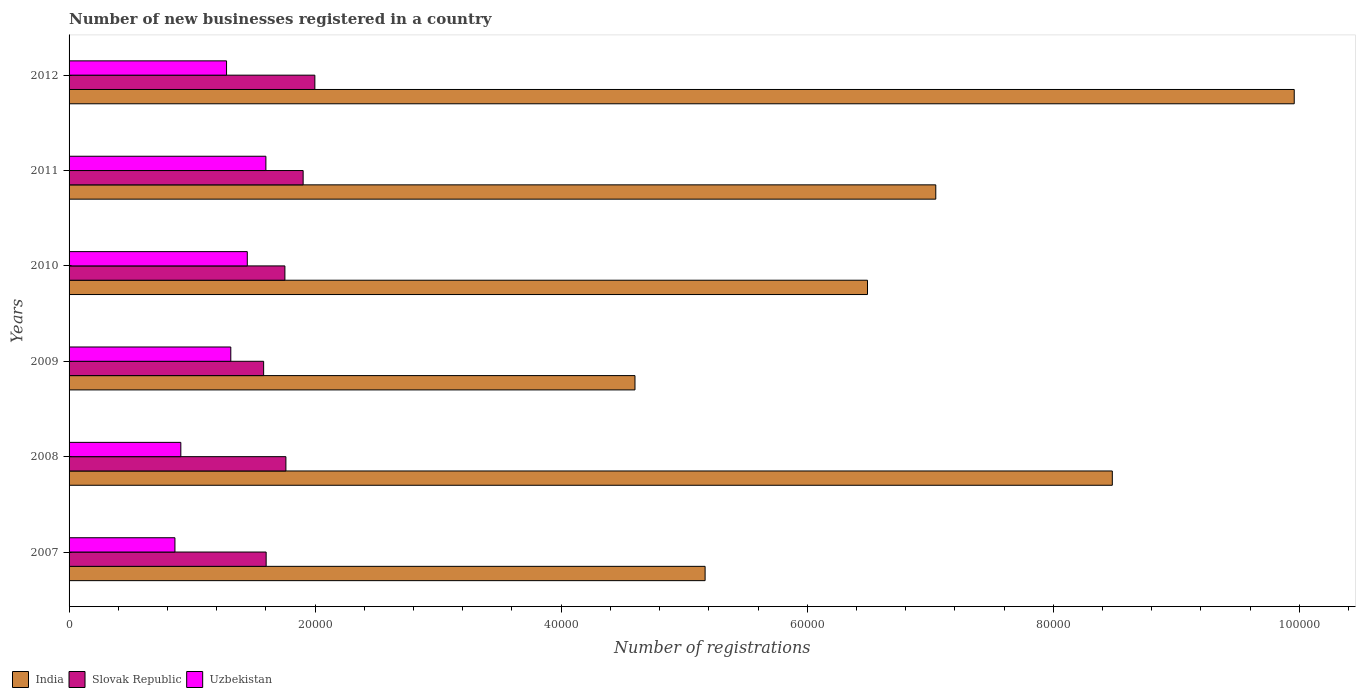How many different coloured bars are there?
Ensure brevity in your answer.  3. How many groups of bars are there?
Keep it short and to the point. 6. Are the number of bars per tick equal to the number of legend labels?
Give a very brief answer. Yes. What is the label of the 5th group of bars from the top?
Offer a terse response. 2008. In how many cases, is the number of bars for a given year not equal to the number of legend labels?
Make the answer very short. 0. What is the number of new businesses registered in Slovak Republic in 2007?
Make the answer very short. 1.60e+04. Across all years, what is the maximum number of new businesses registered in India?
Give a very brief answer. 9.96e+04. Across all years, what is the minimum number of new businesses registered in Slovak Republic?
Your answer should be very brief. 1.58e+04. In which year was the number of new businesses registered in Slovak Republic minimum?
Ensure brevity in your answer.  2009. What is the total number of new businesses registered in Uzbekistan in the graph?
Provide a short and direct response. 7.41e+04. What is the difference between the number of new businesses registered in India in 2010 and that in 2011?
Ensure brevity in your answer.  -5550. What is the difference between the number of new businesses registered in Uzbekistan in 2011 and the number of new businesses registered in Slovak Republic in 2008?
Offer a terse response. -1626. What is the average number of new businesses registered in Slovak Republic per year?
Your answer should be compact. 1.77e+04. In the year 2012, what is the difference between the number of new businesses registered in Slovak Republic and number of new businesses registered in Uzbekistan?
Provide a short and direct response. 7178. What is the ratio of the number of new businesses registered in Uzbekistan in 2007 to that in 2011?
Offer a terse response. 0.54. Is the difference between the number of new businesses registered in Slovak Republic in 2007 and 2010 greater than the difference between the number of new businesses registered in Uzbekistan in 2007 and 2010?
Offer a very short reply. Yes. What is the difference between the highest and the second highest number of new businesses registered in India?
Your answer should be compact. 1.48e+04. What is the difference between the highest and the lowest number of new businesses registered in Slovak Republic?
Provide a succinct answer. 4164. What does the 3rd bar from the top in 2011 represents?
Offer a very short reply. India. What does the 3rd bar from the bottom in 2011 represents?
Provide a short and direct response. Uzbekistan. Is it the case that in every year, the sum of the number of new businesses registered in Slovak Republic and number of new businesses registered in India is greater than the number of new businesses registered in Uzbekistan?
Offer a very short reply. Yes. How many years are there in the graph?
Your answer should be compact. 6. Does the graph contain any zero values?
Your response must be concise. No. How are the legend labels stacked?
Offer a very short reply. Horizontal. What is the title of the graph?
Keep it short and to the point. Number of new businesses registered in a country. Does "United Kingdom" appear as one of the legend labels in the graph?
Keep it short and to the point. No. What is the label or title of the X-axis?
Make the answer very short. Number of registrations. What is the label or title of the Y-axis?
Give a very brief answer. Years. What is the Number of registrations of India in 2007?
Keep it short and to the point. 5.17e+04. What is the Number of registrations in Slovak Republic in 2007?
Offer a terse response. 1.60e+04. What is the Number of registrations of Uzbekistan in 2007?
Give a very brief answer. 8605. What is the Number of registrations in India in 2008?
Provide a short and direct response. 8.48e+04. What is the Number of registrations of Slovak Republic in 2008?
Make the answer very short. 1.76e+04. What is the Number of registrations of Uzbekistan in 2008?
Ensure brevity in your answer.  9084. What is the Number of registrations of India in 2009?
Provide a succinct answer. 4.60e+04. What is the Number of registrations of Slovak Republic in 2009?
Keep it short and to the point. 1.58e+04. What is the Number of registrations in Uzbekistan in 2009?
Make the answer very short. 1.31e+04. What is the Number of registrations of India in 2010?
Offer a very short reply. 6.49e+04. What is the Number of registrations in Slovak Republic in 2010?
Ensure brevity in your answer.  1.75e+04. What is the Number of registrations in Uzbekistan in 2010?
Provide a succinct answer. 1.45e+04. What is the Number of registrations of India in 2011?
Provide a short and direct response. 7.04e+04. What is the Number of registrations in Slovak Republic in 2011?
Offer a terse response. 1.90e+04. What is the Number of registrations in Uzbekistan in 2011?
Provide a short and direct response. 1.60e+04. What is the Number of registrations of India in 2012?
Your response must be concise. 9.96e+04. What is the Number of registrations of Slovak Republic in 2012?
Keep it short and to the point. 2.00e+04. What is the Number of registrations of Uzbekistan in 2012?
Keep it short and to the point. 1.28e+04. Across all years, what is the maximum Number of registrations in India?
Offer a terse response. 9.96e+04. Across all years, what is the maximum Number of registrations in Slovak Republic?
Make the answer very short. 2.00e+04. Across all years, what is the maximum Number of registrations in Uzbekistan?
Keep it short and to the point. 1.60e+04. Across all years, what is the minimum Number of registrations of India?
Ensure brevity in your answer.  4.60e+04. Across all years, what is the minimum Number of registrations in Slovak Republic?
Keep it short and to the point. 1.58e+04. Across all years, what is the minimum Number of registrations of Uzbekistan?
Make the answer very short. 8605. What is the total Number of registrations of India in the graph?
Provide a succinct answer. 4.17e+05. What is the total Number of registrations of Slovak Republic in the graph?
Give a very brief answer. 1.06e+05. What is the total Number of registrations of Uzbekistan in the graph?
Your response must be concise. 7.41e+04. What is the difference between the Number of registrations in India in 2007 and that in 2008?
Ensure brevity in your answer.  -3.31e+04. What is the difference between the Number of registrations in Slovak Republic in 2007 and that in 2008?
Make the answer very short. -1605. What is the difference between the Number of registrations in Uzbekistan in 2007 and that in 2008?
Your answer should be very brief. -479. What is the difference between the Number of registrations in India in 2007 and that in 2009?
Provide a succinct answer. 5700. What is the difference between the Number of registrations in Slovak Republic in 2007 and that in 2009?
Offer a terse response. 205. What is the difference between the Number of registrations in Uzbekistan in 2007 and that in 2009?
Your response must be concise. -4541. What is the difference between the Number of registrations of India in 2007 and that in 2010?
Provide a short and direct response. -1.32e+04. What is the difference between the Number of registrations in Slovak Republic in 2007 and that in 2010?
Keep it short and to the point. -1524. What is the difference between the Number of registrations in Uzbekistan in 2007 and that in 2010?
Give a very brief answer. -5882. What is the difference between the Number of registrations of India in 2007 and that in 2011?
Your response must be concise. -1.88e+04. What is the difference between the Number of registrations in Slovak Republic in 2007 and that in 2011?
Keep it short and to the point. -3006. What is the difference between the Number of registrations in Uzbekistan in 2007 and that in 2011?
Offer a very short reply. -7394. What is the difference between the Number of registrations in India in 2007 and that in 2012?
Provide a succinct answer. -4.79e+04. What is the difference between the Number of registrations of Slovak Republic in 2007 and that in 2012?
Your answer should be very brief. -3959. What is the difference between the Number of registrations of Uzbekistan in 2007 and that in 2012?
Your answer should be very brief. -4196. What is the difference between the Number of registrations of India in 2008 and that in 2009?
Ensure brevity in your answer.  3.88e+04. What is the difference between the Number of registrations of Slovak Republic in 2008 and that in 2009?
Ensure brevity in your answer.  1810. What is the difference between the Number of registrations in Uzbekistan in 2008 and that in 2009?
Your answer should be very brief. -4062. What is the difference between the Number of registrations of India in 2008 and that in 2010?
Offer a very short reply. 1.99e+04. What is the difference between the Number of registrations in Slovak Republic in 2008 and that in 2010?
Offer a terse response. 81. What is the difference between the Number of registrations of Uzbekistan in 2008 and that in 2010?
Provide a short and direct response. -5403. What is the difference between the Number of registrations of India in 2008 and that in 2011?
Your answer should be compact. 1.44e+04. What is the difference between the Number of registrations of Slovak Republic in 2008 and that in 2011?
Give a very brief answer. -1401. What is the difference between the Number of registrations in Uzbekistan in 2008 and that in 2011?
Your answer should be very brief. -6915. What is the difference between the Number of registrations in India in 2008 and that in 2012?
Give a very brief answer. -1.48e+04. What is the difference between the Number of registrations of Slovak Republic in 2008 and that in 2012?
Ensure brevity in your answer.  -2354. What is the difference between the Number of registrations of Uzbekistan in 2008 and that in 2012?
Keep it short and to the point. -3717. What is the difference between the Number of registrations in India in 2009 and that in 2010?
Your response must be concise. -1.89e+04. What is the difference between the Number of registrations in Slovak Republic in 2009 and that in 2010?
Your answer should be compact. -1729. What is the difference between the Number of registrations in Uzbekistan in 2009 and that in 2010?
Provide a short and direct response. -1341. What is the difference between the Number of registrations of India in 2009 and that in 2011?
Your answer should be very brief. -2.44e+04. What is the difference between the Number of registrations in Slovak Republic in 2009 and that in 2011?
Offer a very short reply. -3211. What is the difference between the Number of registrations in Uzbekistan in 2009 and that in 2011?
Give a very brief answer. -2853. What is the difference between the Number of registrations in India in 2009 and that in 2012?
Offer a very short reply. -5.36e+04. What is the difference between the Number of registrations of Slovak Republic in 2009 and that in 2012?
Ensure brevity in your answer.  -4164. What is the difference between the Number of registrations in Uzbekistan in 2009 and that in 2012?
Keep it short and to the point. 345. What is the difference between the Number of registrations of India in 2010 and that in 2011?
Your answer should be very brief. -5550. What is the difference between the Number of registrations of Slovak Republic in 2010 and that in 2011?
Your answer should be very brief. -1482. What is the difference between the Number of registrations of Uzbekistan in 2010 and that in 2011?
Give a very brief answer. -1512. What is the difference between the Number of registrations in India in 2010 and that in 2012?
Your answer should be compact. -3.47e+04. What is the difference between the Number of registrations of Slovak Republic in 2010 and that in 2012?
Offer a very short reply. -2435. What is the difference between the Number of registrations of Uzbekistan in 2010 and that in 2012?
Your response must be concise. 1686. What is the difference between the Number of registrations in India in 2011 and that in 2012?
Your response must be concise. -2.91e+04. What is the difference between the Number of registrations of Slovak Republic in 2011 and that in 2012?
Make the answer very short. -953. What is the difference between the Number of registrations in Uzbekistan in 2011 and that in 2012?
Offer a very short reply. 3198. What is the difference between the Number of registrations in India in 2007 and the Number of registrations in Slovak Republic in 2008?
Offer a very short reply. 3.41e+04. What is the difference between the Number of registrations in India in 2007 and the Number of registrations in Uzbekistan in 2008?
Your answer should be compact. 4.26e+04. What is the difference between the Number of registrations of Slovak Republic in 2007 and the Number of registrations of Uzbekistan in 2008?
Your response must be concise. 6936. What is the difference between the Number of registrations in India in 2007 and the Number of registrations in Slovak Republic in 2009?
Your response must be concise. 3.59e+04. What is the difference between the Number of registrations of India in 2007 and the Number of registrations of Uzbekistan in 2009?
Keep it short and to the point. 3.86e+04. What is the difference between the Number of registrations of Slovak Republic in 2007 and the Number of registrations of Uzbekistan in 2009?
Ensure brevity in your answer.  2874. What is the difference between the Number of registrations of India in 2007 and the Number of registrations of Slovak Republic in 2010?
Make the answer very short. 3.42e+04. What is the difference between the Number of registrations of India in 2007 and the Number of registrations of Uzbekistan in 2010?
Provide a short and direct response. 3.72e+04. What is the difference between the Number of registrations of Slovak Republic in 2007 and the Number of registrations of Uzbekistan in 2010?
Your answer should be very brief. 1533. What is the difference between the Number of registrations in India in 2007 and the Number of registrations in Slovak Republic in 2011?
Offer a very short reply. 3.27e+04. What is the difference between the Number of registrations of India in 2007 and the Number of registrations of Uzbekistan in 2011?
Your response must be concise. 3.57e+04. What is the difference between the Number of registrations in Slovak Republic in 2007 and the Number of registrations in Uzbekistan in 2011?
Give a very brief answer. 21. What is the difference between the Number of registrations of India in 2007 and the Number of registrations of Slovak Republic in 2012?
Ensure brevity in your answer.  3.17e+04. What is the difference between the Number of registrations of India in 2007 and the Number of registrations of Uzbekistan in 2012?
Make the answer very short. 3.89e+04. What is the difference between the Number of registrations of Slovak Republic in 2007 and the Number of registrations of Uzbekistan in 2012?
Provide a short and direct response. 3219. What is the difference between the Number of registrations in India in 2008 and the Number of registrations in Slovak Republic in 2009?
Provide a short and direct response. 6.90e+04. What is the difference between the Number of registrations in India in 2008 and the Number of registrations in Uzbekistan in 2009?
Provide a succinct answer. 7.17e+04. What is the difference between the Number of registrations of Slovak Republic in 2008 and the Number of registrations of Uzbekistan in 2009?
Your answer should be compact. 4479. What is the difference between the Number of registrations of India in 2008 and the Number of registrations of Slovak Republic in 2010?
Your response must be concise. 6.73e+04. What is the difference between the Number of registrations in India in 2008 and the Number of registrations in Uzbekistan in 2010?
Your answer should be very brief. 7.03e+04. What is the difference between the Number of registrations of Slovak Republic in 2008 and the Number of registrations of Uzbekistan in 2010?
Offer a terse response. 3138. What is the difference between the Number of registrations of India in 2008 and the Number of registrations of Slovak Republic in 2011?
Your answer should be compact. 6.58e+04. What is the difference between the Number of registrations in India in 2008 and the Number of registrations in Uzbekistan in 2011?
Offer a terse response. 6.88e+04. What is the difference between the Number of registrations of Slovak Republic in 2008 and the Number of registrations of Uzbekistan in 2011?
Provide a short and direct response. 1626. What is the difference between the Number of registrations in India in 2008 and the Number of registrations in Slovak Republic in 2012?
Provide a short and direct response. 6.48e+04. What is the difference between the Number of registrations in India in 2008 and the Number of registrations in Uzbekistan in 2012?
Your answer should be very brief. 7.20e+04. What is the difference between the Number of registrations in Slovak Republic in 2008 and the Number of registrations in Uzbekistan in 2012?
Make the answer very short. 4824. What is the difference between the Number of registrations of India in 2009 and the Number of registrations of Slovak Republic in 2010?
Your answer should be very brief. 2.85e+04. What is the difference between the Number of registrations in India in 2009 and the Number of registrations in Uzbekistan in 2010?
Your answer should be compact. 3.15e+04. What is the difference between the Number of registrations of Slovak Republic in 2009 and the Number of registrations of Uzbekistan in 2010?
Your response must be concise. 1328. What is the difference between the Number of registrations of India in 2009 and the Number of registrations of Slovak Republic in 2011?
Offer a terse response. 2.70e+04. What is the difference between the Number of registrations of India in 2009 and the Number of registrations of Uzbekistan in 2011?
Provide a short and direct response. 3.00e+04. What is the difference between the Number of registrations of Slovak Republic in 2009 and the Number of registrations of Uzbekistan in 2011?
Your answer should be very brief. -184. What is the difference between the Number of registrations in India in 2009 and the Number of registrations in Slovak Republic in 2012?
Give a very brief answer. 2.60e+04. What is the difference between the Number of registrations in India in 2009 and the Number of registrations in Uzbekistan in 2012?
Keep it short and to the point. 3.32e+04. What is the difference between the Number of registrations in Slovak Republic in 2009 and the Number of registrations in Uzbekistan in 2012?
Provide a succinct answer. 3014. What is the difference between the Number of registrations of India in 2010 and the Number of registrations of Slovak Republic in 2011?
Offer a very short reply. 4.59e+04. What is the difference between the Number of registrations in India in 2010 and the Number of registrations in Uzbekistan in 2011?
Provide a short and direct response. 4.89e+04. What is the difference between the Number of registrations in Slovak Republic in 2010 and the Number of registrations in Uzbekistan in 2011?
Give a very brief answer. 1545. What is the difference between the Number of registrations of India in 2010 and the Number of registrations of Slovak Republic in 2012?
Your answer should be very brief. 4.49e+04. What is the difference between the Number of registrations of India in 2010 and the Number of registrations of Uzbekistan in 2012?
Ensure brevity in your answer.  5.21e+04. What is the difference between the Number of registrations in Slovak Republic in 2010 and the Number of registrations in Uzbekistan in 2012?
Offer a very short reply. 4743. What is the difference between the Number of registrations in India in 2011 and the Number of registrations in Slovak Republic in 2012?
Your answer should be very brief. 5.05e+04. What is the difference between the Number of registrations in India in 2011 and the Number of registrations in Uzbekistan in 2012?
Your answer should be very brief. 5.76e+04. What is the difference between the Number of registrations in Slovak Republic in 2011 and the Number of registrations in Uzbekistan in 2012?
Provide a succinct answer. 6225. What is the average Number of registrations of India per year?
Keep it short and to the point. 6.96e+04. What is the average Number of registrations in Slovak Republic per year?
Make the answer very short. 1.77e+04. What is the average Number of registrations in Uzbekistan per year?
Your answer should be very brief. 1.24e+04. In the year 2007, what is the difference between the Number of registrations in India and Number of registrations in Slovak Republic?
Make the answer very short. 3.57e+04. In the year 2007, what is the difference between the Number of registrations of India and Number of registrations of Uzbekistan?
Provide a succinct answer. 4.31e+04. In the year 2007, what is the difference between the Number of registrations in Slovak Republic and Number of registrations in Uzbekistan?
Your answer should be very brief. 7415. In the year 2008, what is the difference between the Number of registrations in India and Number of registrations in Slovak Republic?
Your answer should be very brief. 6.72e+04. In the year 2008, what is the difference between the Number of registrations in India and Number of registrations in Uzbekistan?
Keep it short and to the point. 7.57e+04. In the year 2008, what is the difference between the Number of registrations in Slovak Republic and Number of registrations in Uzbekistan?
Your response must be concise. 8541. In the year 2009, what is the difference between the Number of registrations of India and Number of registrations of Slovak Republic?
Your answer should be very brief. 3.02e+04. In the year 2009, what is the difference between the Number of registrations in India and Number of registrations in Uzbekistan?
Give a very brief answer. 3.29e+04. In the year 2009, what is the difference between the Number of registrations of Slovak Republic and Number of registrations of Uzbekistan?
Offer a terse response. 2669. In the year 2010, what is the difference between the Number of registrations in India and Number of registrations in Slovak Republic?
Offer a very short reply. 4.74e+04. In the year 2010, what is the difference between the Number of registrations in India and Number of registrations in Uzbekistan?
Offer a terse response. 5.04e+04. In the year 2010, what is the difference between the Number of registrations in Slovak Republic and Number of registrations in Uzbekistan?
Offer a terse response. 3057. In the year 2011, what is the difference between the Number of registrations in India and Number of registrations in Slovak Republic?
Provide a short and direct response. 5.14e+04. In the year 2011, what is the difference between the Number of registrations in India and Number of registrations in Uzbekistan?
Provide a short and direct response. 5.45e+04. In the year 2011, what is the difference between the Number of registrations in Slovak Republic and Number of registrations in Uzbekistan?
Your answer should be compact. 3027. In the year 2012, what is the difference between the Number of registrations of India and Number of registrations of Slovak Republic?
Provide a succinct answer. 7.96e+04. In the year 2012, what is the difference between the Number of registrations of India and Number of registrations of Uzbekistan?
Provide a short and direct response. 8.68e+04. In the year 2012, what is the difference between the Number of registrations in Slovak Republic and Number of registrations in Uzbekistan?
Keep it short and to the point. 7178. What is the ratio of the Number of registrations of India in 2007 to that in 2008?
Ensure brevity in your answer.  0.61. What is the ratio of the Number of registrations of Slovak Republic in 2007 to that in 2008?
Give a very brief answer. 0.91. What is the ratio of the Number of registrations in Uzbekistan in 2007 to that in 2008?
Provide a short and direct response. 0.95. What is the ratio of the Number of registrations of India in 2007 to that in 2009?
Provide a short and direct response. 1.12. What is the ratio of the Number of registrations in Uzbekistan in 2007 to that in 2009?
Your answer should be very brief. 0.65. What is the ratio of the Number of registrations of India in 2007 to that in 2010?
Offer a terse response. 0.8. What is the ratio of the Number of registrations in Slovak Republic in 2007 to that in 2010?
Give a very brief answer. 0.91. What is the ratio of the Number of registrations of Uzbekistan in 2007 to that in 2010?
Provide a succinct answer. 0.59. What is the ratio of the Number of registrations in India in 2007 to that in 2011?
Offer a terse response. 0.73. What is the ratio of the Number of registrations in Slovak Republic in 2007 to that in 2011?
Provide a short and direct response. 0.84. What is the ratio of the Number of registrations of Uzbekistan in 2007 to that in 2011?
Give a very brief answer. 0.54. What is the ratio of the Number of registrations in India in 2007 to that in 2012?
Offer a terse response. 0.52. What is the ratio of the Number of registrations in Slovak Republic in 2007 to that in 2012?
Your answer should be very brief. 0.8. What is the ratio of the Number of registrations in Uzbekistan in 2007 to that in 2012?
Provide a succinct answer. 0.67. What is the ratio of the Number of registrations of India in 2008 to that in 2009?
Offer a terse response. 1.84. What is the ratio of the Number of registrations of Slovak Republic in 2008 to that in 2009?
Keep it short and to the point. 1.11. What is the ratio of the Number of registrations of Uzbekistan in 2008 to that in 2009?
Your answer should be very brief. 0.69. What is the ratio of the Number of registrations of India in 2008 to that in 2010?
Your answer should be very brief. 1.31. What is the ratio of the Number of registrations in Uzbekistan in 2008 to that in 2010?
Your answer should be compact. 0.63. What is the ratio of the Number of registrations in India in 2008 to that in 2011?
Ensure brevity in your answer.  1.2. What is the ratio of the Number of registrations in Slovak Republic in 2008 to that in 2011?
Your response must be concise. 0.93. What is the ratio of the Number of registrations of Uzbekistan in 2008 to that in 2011?
Keep it short and to the point. 0.57. What is the ratio of the Number of registrations of India in 2008 to that in 2012?
Your answer should be compact. 0.85. What is the ratio of the Number of registrations in Slovak Republic in 2008 to that in 2012?
Your answer should be very brief. 0.88. What is the ratio of the Number of registrations of Uzbekistan in 2008 to that in 2012?
Keep it short and to the point. 0.71. What is the ratio of the Number of registrations in India in 2009 to that in 2010?
Keep it short and to the point. 0.71. What is the ratio of the Number of registrations of Slovak Republic in 2009 to that in 2010?
Your answer should be very brief. 0.9. What is the ratio of the Number of registrations in Uzbekistan in 2009 to that in 2010?
Your response must be concise. 0.91. What is the ratio of the Number of registrations of India in 2009 to that in 2011?
Keep it short and to the point. 0.65. What is the ratio of the Number of registrations of Slovak Republic in 2009 to that in 2011?
Your answer should be very brief. 0.83. What is the ratio of the Number of registrations in Uzbekistan in 2009 to that in 2011?
Make the answer very short. 0.82. What is the ratio of the Number of registrations in India in 2009 to that in 2012?
Make the answer very short. 0.46. What is the ratio of the Number of registrations of Slovak Republic in 2009 to that in 2012?
Your answer should be very brief. 0.79. What is the ratio of the Number of registrations of India in 2010 to that in 2011?
Ensure brevity in your answer.  0.92. What is the ratio of the Number of registrations of Slovak Republic in 2010 to that in 2011?
Offer a terse response. 0.92. What is the ratio of the Number of registrations in Uzbekistan in 2010 to that in 2011?
Give a very brief answer. 0.91. What is the ratio of the Number of registrations in India in 2010 to that in 2012?
Provide a short and direct response. 0.65. What is the ratio of the Number of registrations of Slovak Republic in 2010 to that in 2012?
Provide a short and direct response. 0.88. What is the ratio of the Number of registrations of Uzbekistan in 2010 to that in 2012?
Ensure brevity in your answer.  1.13. What is the ratio of the Number of registrations of India in 2011 to that in 2012?
Offer a very short reply. 0.71. What is the ratio of the Number of registrations of Slovak Republic in 2011 to that in 2012?
Provide a short and direct response. 0.95. What is the ratio of the Number of registrations in Uzbekistan in 2011 to that in 2012?
Provide a succinct answer. 1.25. What is the difference between the highest and the second highest Number of registrations in India?
Your answer should be very brief. 1.48e+04. What is the difference between the highest and the second highest Number of registrations in Slovak Republic?
Give a very brief answer. 953. What is the difference between the highest and the second highest Number of registrations of Uzbekistan?
Provide a succinct answer. 1512. What is the difference between the highest and the lowest Number of registrations of India?
Provide a succinct answer. 5.36e+04. What is the difference between the highest and the lowest Number of registrations of Slovak Republic?
Your response must be concise. 4164. What is the difference between the highest and the lowest Number of registrations of Uzbekistan?
Make the answer very short. 7394. 